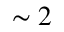<formula> <loc_0><loc_0><loc_500><loc_500>\sim 2</formula> 